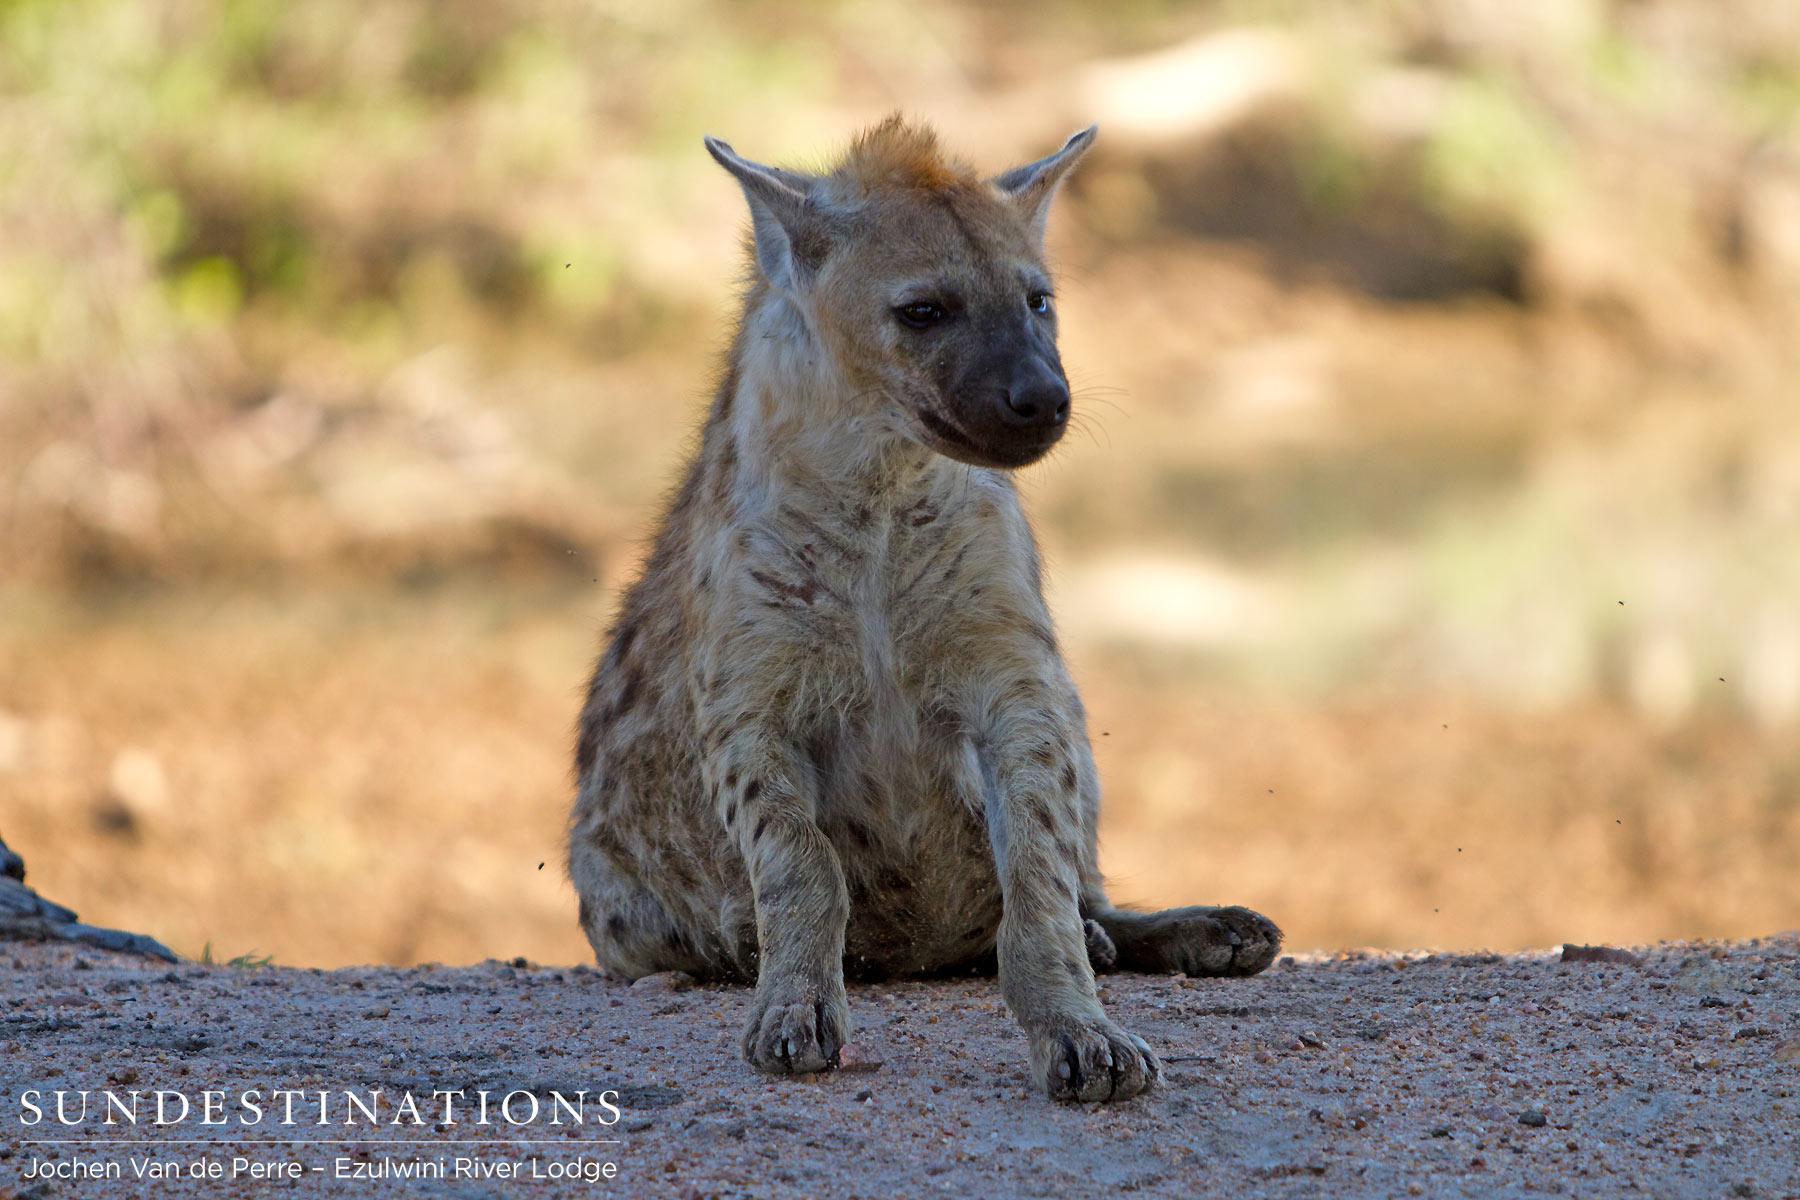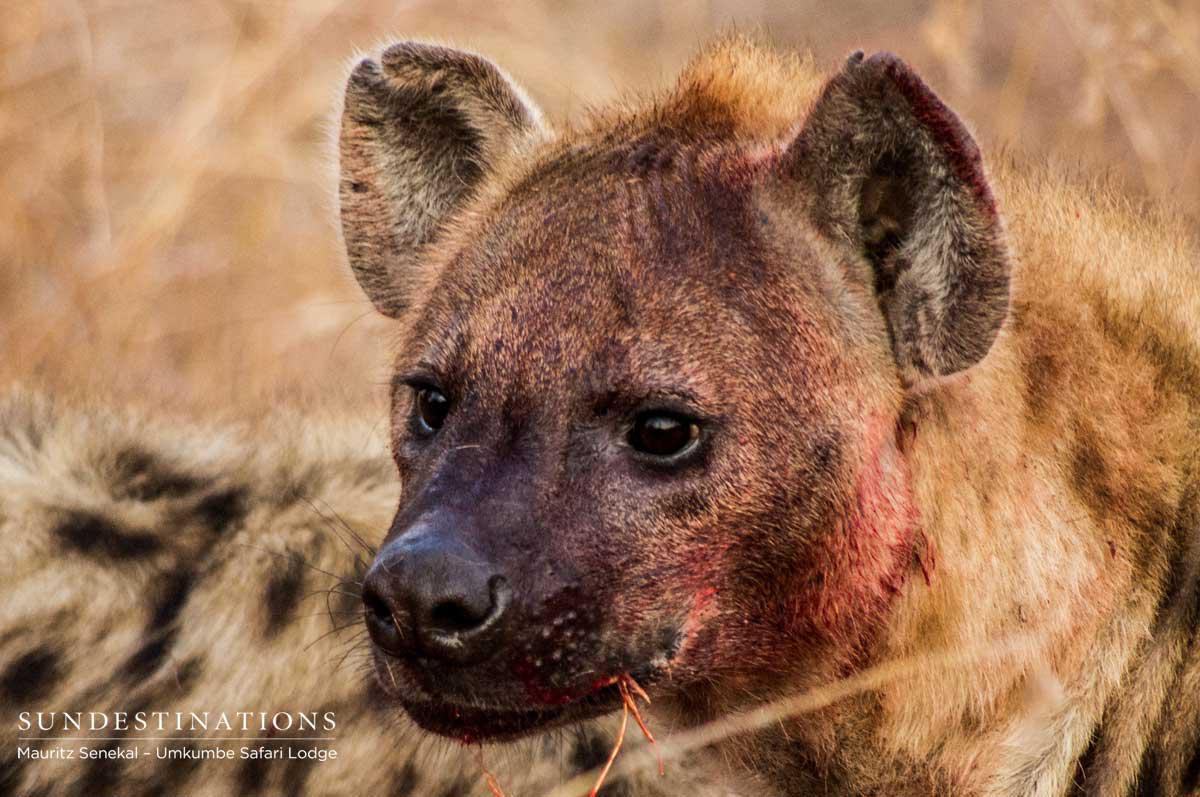The first image is the image on the left, the second image is the image on the right. Examine the images to the left and right. Is the description "The left image shows a hyena standing with its body turned leftward, and the right image includes a hyena with opened mouth showing teeth." accurate? Answer yes or no. No. The first image is the image on the left, the second image is the image on the right. Analyze the images presented: Is the assertion "A hyena is standing in a field in the image on the left." valid? Answer yes or no. No. 